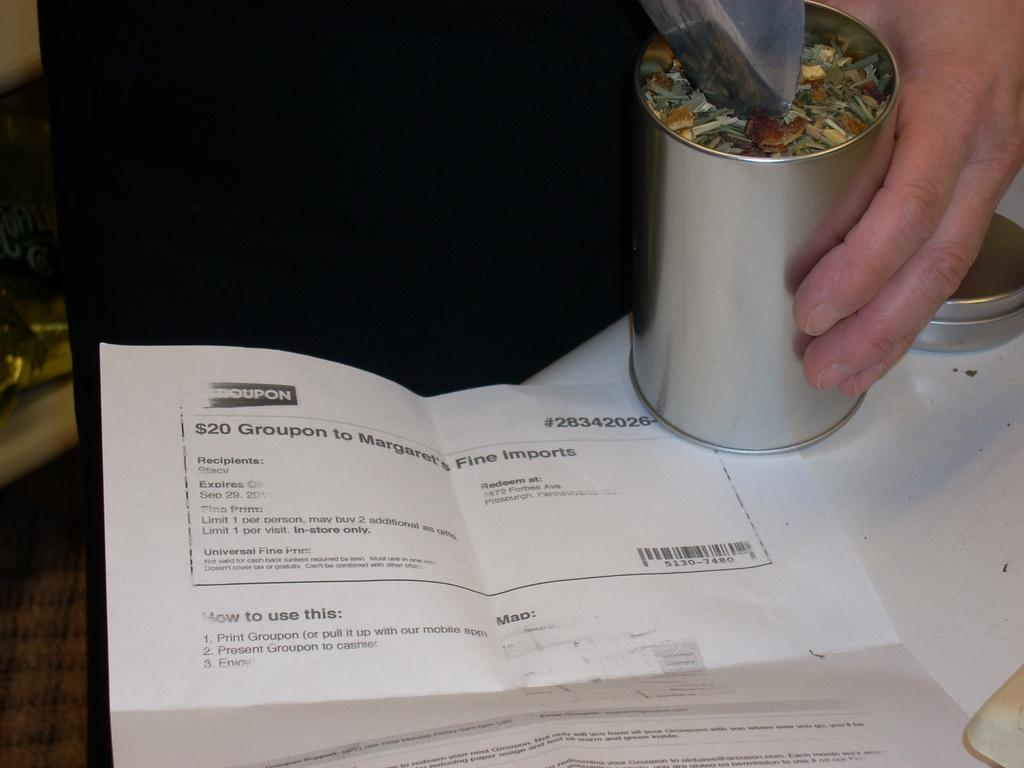What is the main subject in the image? There is a person in the image. What object is present in the image that the person might use? There is a table in the image. What can be seen on the table? There is a glass and a paper on the table. What type of mind-reading abilities does the person in the image possess? There is no indication in the image that the person has any mind-reading abilities. 